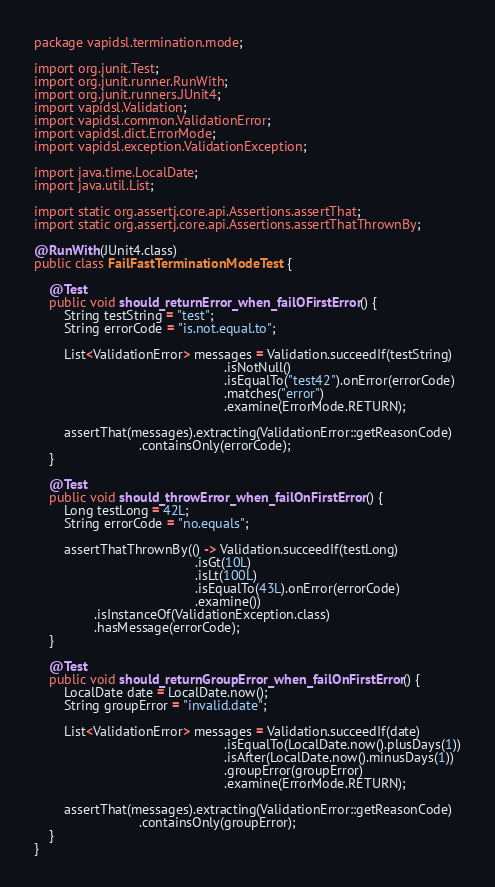<code> <loc_0><loc_0><loc_500><loc_500><_Java_>package vapidsl.termination.mode;

import org.junit.Test;
import org.junit.runner.RunWith;
import org.junit.runners.JUnit4;
import vapidsl.Validation;
import vapidsl.common.ValidationError;
import vapidsl.dict.ErrorMode;
import vapidsl.exception.ValidationException;

import java.time.LocalDate;
import java.util.List;

import static org.assertj.core.api.Assertions.assertThat;
import static org.assertj.core.api.Assertions.assertThatThrownBy;

@RunWith(JUnit4.class)
public class FailFastTerminationModeTest {

    @Test
    public void should_returnError_when_failOFirstError() {
        String testString = "test";
        String errorCode = "is.not.equal.to";

        List<ValidationError> messages = Validation.succeedIf(testString)
                                                   .isNotNull()
                                                   .isEqualTo("test42").onError(errorCode)
                                                   .matches("error")
                                                   .examine(ErrorMode.RETURN);

        assertThat(messages).extracting(ValidationError::getReasonCode)
                            .containsOnly(errorCode);
    }

    @Test
    public void should_throwError_when_failOnFirstError() {
        Long testLong = 42L;
        String errorCode = "no.equals";

        assertThatThrownBy(() -> Validation.succeedIf(testLong)
                                           .isGt(10L)
                                           .isLt(100L)
                                           .isEqualTo(43L).onError(errorCode)
                                           .examine())
                .isInstanceOf(ValidationException.class)
                .hasMessage(errorCode);
    }

    @Test
    public void should_returnGroupError_when_failOnFirstError() {
        LocalDate date = LocalDate.now();
        String groupError = "invalid.date";

        List<ValidationError> messages = Validation.succeedIf(date)
                                                   .isEqualTo(LocalDate.now().plusDays(1))
                                                   .isAfter(LocalDate.now().minusDays(1))
                                                   .groupError(groupError)
                                                   .examine(ErrorMode.RETURN);

        assertThat(messages).extracting(ValidationError::getReasonCode)
                            .containsOnly(groupError);
    }
}
</code> 